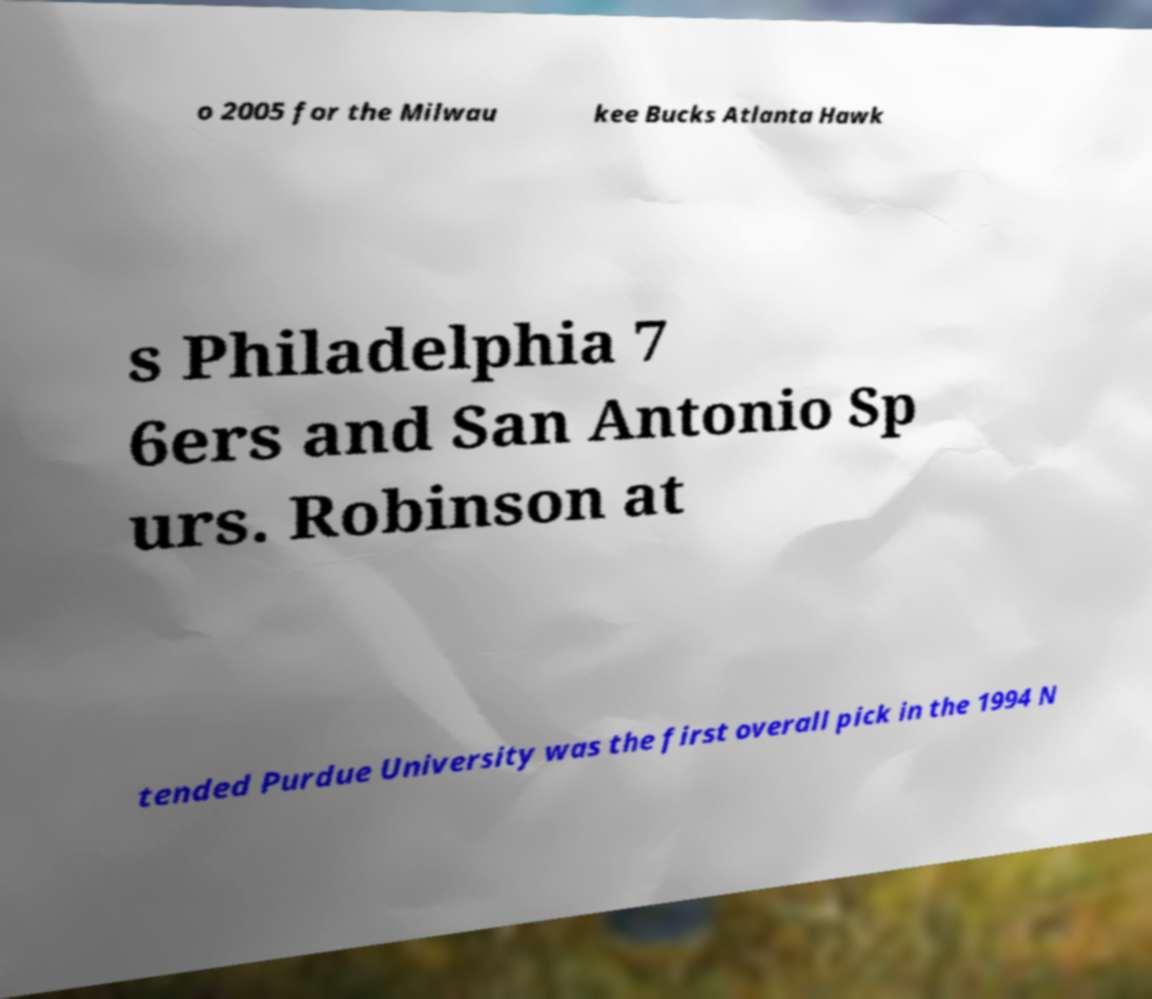Please identify and transcribe the text found in this image. o 2005 for the Milwau kee Bucks Atlanta Hawk s Philadelphia 7 6ers and San Antonio Sp urs. Robinson at tended Purdue University was the first overall pick in the 1994 N 